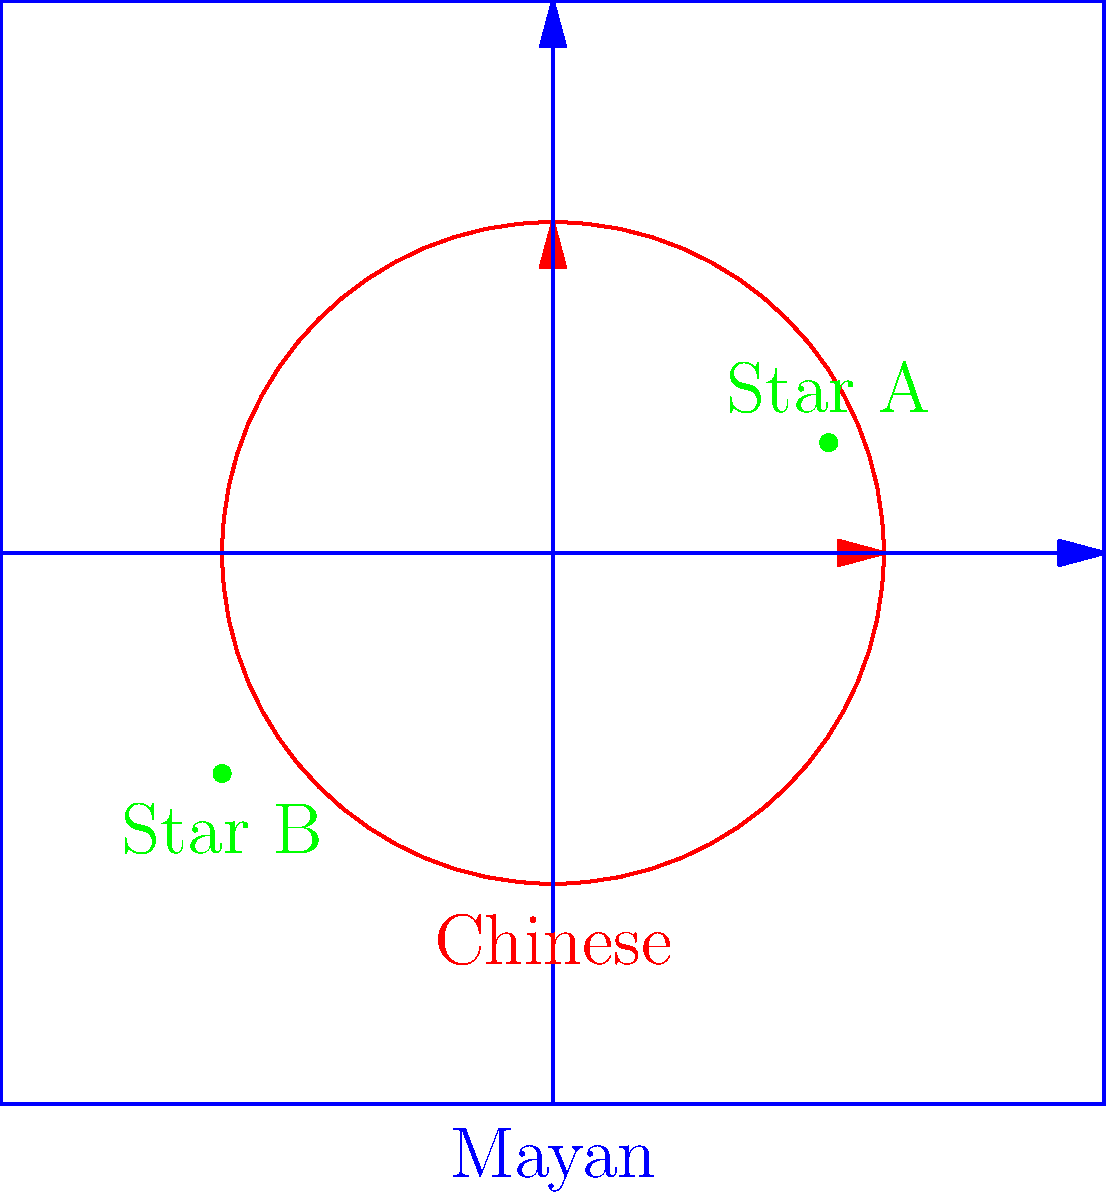In the comparative analysis of ancient Chinese and Mayan astronomical coordinate systems shown above, which system would be more efficient for precisely tracking the position of Star A over time, and why? To answer this question, we need to consider the characteristics of both coordinate systems and their suitability for tracking Star A's position:

1. Chinese system (red):
   - Circular coordinate system
   - Similar to modern celestial sphere coordinates
   - Efficient for tracking objects that appear to move in circular paths across the sky
   - Star A is located in the upper-right quadrant, easily describable using angular coordinates

2. Mayan system (blue):
   - Rectangular coordinate system
   - Similar to modern Cartesian coordinates
   - Efficient for describing positions in a flat plane
   - Star A's position can be described using x and y coordinates

3. Star A's position:
   - Located in the upper-right quadrant of both systems
   - Closer to the edge in the Chinese system
   - Roughly in the middle of the Mayan system's grid

4. Tracking over time:
   - Stars appear to move in circular paths due to Earth's rotation
   - The Chinese system naturally accommodates this circular motion
   - The Mayan system would require more complex calculations to track circular motion

5. Precision considerations:
   - The Chinese system can easily describe small angular changes
   - The Mayan system might require finer grid divisions for precise tracking

Given these factors, the Chinese circular coordinate system would be more efficient for precisely tracking Star A's position over time. It naturally aligns with the apparent circular motion of stars in the night sky, allowing for easier and more intuitive tracking of celestial objects.
Answer: Chinese system; aligns with apparent circular motion of stars 